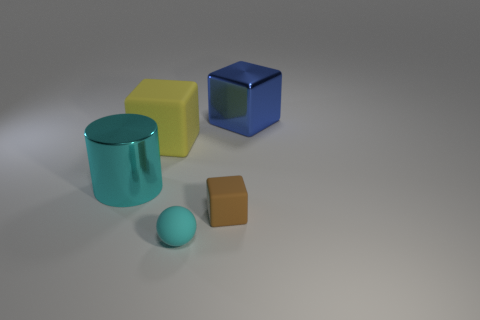What number of other objects are there of the same color as the shiny cube?
Your answer should be compact. 0. Is there a cyan shiny thing of the same shape as the yellow object?
Keep it short and to the point. No. There is a large cylinder that is the same color as the small matte sphere; what is its material?
Your answer should be compact. Metal. What number of metallic objects are large gray spheres or small cyan balls?
Give a very brief answer. 0. What shape is the big cyan thing?
Provide a succinct answer. Cylinder. How many big blue things are made of the same material as the large cyan object?
Make the answer very short. 1. What color is the large cube that is the same material as the small brown cube?
Offer a very short reply. Yellow. Does the shiny thing in front of the blue thing have the same size as the small cyan matte ball?
Ensure brevity in your answer.  No. There is another matte thing that is the same shape as the brown object; what color is it?
Give a very brief answer. Yellow. There is a large shiny thing right of the big metal object that is in front of the big cube right of the sphere; what is its shape?
Your answer should be very brief. Cube. 